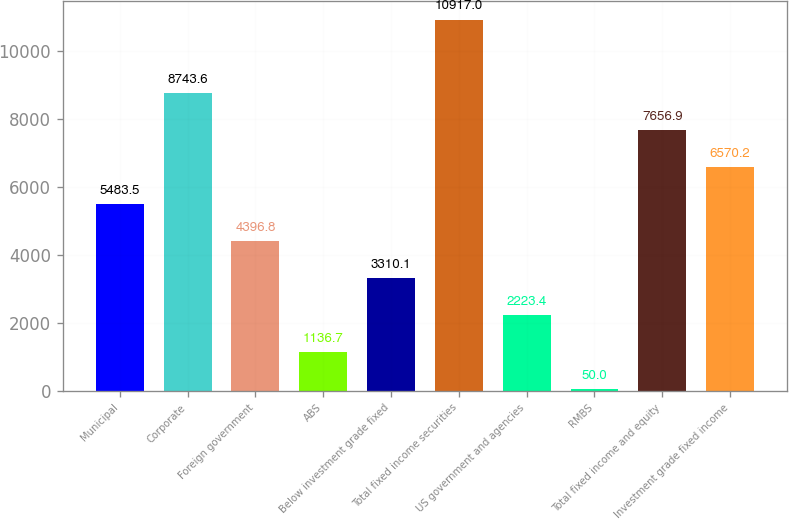<chart> <loc_0><loc_0><loc_500><loc_500><bar_chart><fcel>Municipal<fcel>Corporate<fcel>Foreign government<fcel>ABS<fcel>Below investment grade fixed<fcel>Total fixed income securities<fcel>US government and agencies<fcel>RMBS<fcel>Total fixed income and equity<fcel>Investment grade fixed income<nl><fcel>5483.5<fcel>8743.6<fcel>4396.8<fcel>1136.7<fcel>3310.1<fcel>10917<fcel>2223.4<fcel>50<fcel>7656.9<fcel>6570.2<nl></chart> 